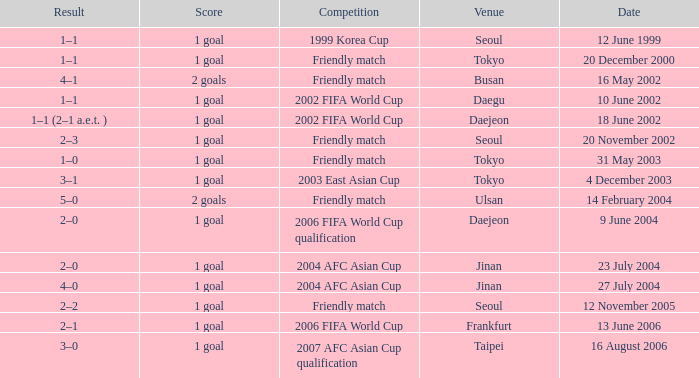What was the score of the game played on 16 August 2006? 1 goal. 